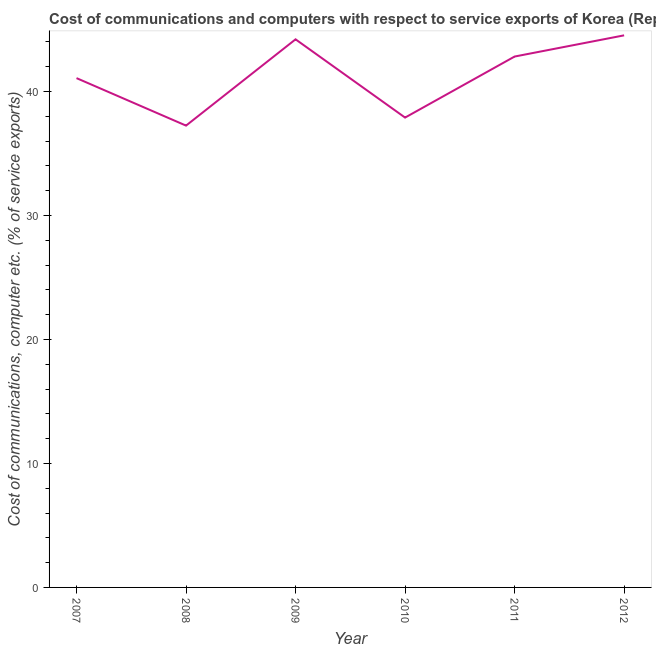What is the cost of communications and computer in 2010?
Offer a very short reply. 37.9. Across all years, what is the maximum cost of communications and computer?
Offer a very short reply. 44.53. Across all years, what is the minimum cost of communications and computer?
Your answer should be compact. 37.25. In which year was the cost of communications and computer maximum?
Give a very brief answer. 2012. In which year was the cost of communications and computer minimum?
Make the answer very short. 2008. What is the sum of the cost of communications and computer?
Make the answer very short. 247.8. What is the difference between the cost of communications and computer in 2010 and 2012?
Your answer should be very brief. -6.63. What is the average cost of communications and computer per year?
Keep it short and to the point. 41.3. What is the median cost of communications and computer?
Give a very brief answer. 41.95. In how many years, is the cost of communications and computer greater than 8 %?
Provide a succinct answer. 6. Do a majority of the years between 2010 and 2009 (inclusive) have cost of communications and computer greater than 16 %?
Provide a succinct answer. No. What is the ratio of the cost of communications and computer in 2008 to that in 2010?
Your answer should be very brief. 0.98. What is the difference between the highest and the second highest cost of communications and computer?
Offer a very short reply. 0.32. What is the difference between the highest and the lowest cost of communications and computer?
Provide a succinct answer. 7.28. How many lines are there?
Ensure brevity in your answer.  1. How many years are there in the graph?
Offer a very short reply. 6. Does the graph contain any zero values?
Your response must be concise. No. What is the title of the graph?
Make the answer very short. Cost of communications and computers with respect to service exports of Korea (Republic). What is the label or title of the Y-axis?
Offer a terse response. Cost of communications, computer etc. (% of service exports). What is the Cost of communications, computer etc. (% of service exports) of 2007?
Provide a succinct answer. 41.08. What is the Cost of communications, computer etc. (% of service exports) in 2008?
Make the answer very short. 37.25. What is the Cost of communications, computer etc. (% of service exports) in 2009?
Your response must be concise. 44.21. What is the Cost of communications, computer etc. (% of service exports) of 2010?
Give a very brief answer. 37.9. What is the Cost of communications, computer etc. (% of service exports) of 2011?
Make the answer very short. 42.82. What is the Cost of communications, computer etc. (% of service exports) of 2012?
Offer a terse response. 44.53. What is the difference between the Cost of communications, computer etc. (% of service exports) in 2007 and 2008?
Provide a short and direct response. 3.83. What is the difference between the Cost of communications, computer etc. (% of service exports) in 2007 and 2009?
Provide a succinct answer. -3.13. What is the difference between the Cost of communications, computer etc. (% of service exports) in 2007 and 2010?
Give a very brief answer. 3.18. What is the difference between the Cost of communications, computer etc. (% of service exports) in 2007 and 2011?
Your response must be concise. -1.74. What is the difference between the Cost of communications, computer etc. (% of service exports) in 2007 and 2012?
Provide a short and direct response. -3.45. What is the difference between the Cost of communications, computer etc. (% of service exports) in 2008 and 2009?
Offer a terse response. -6.96. What is the difference between the Cost of communications, computer etc. (% of service exports) in 2008 and 2010?
Offer a terse response. -0.65. What is the difference between the Cost of communications, computer etc. (% of service exports) in 2008 and 2011?
Give a very brief answer. -5.57. What is the difference between the Cost of communications, computer etc. (% of service exports) in 2008 and 2012?
Ensure brevity in your answer.  -7.28. What is the difference between the Cost of communications, computer etc. (% of service exports) in 2009 and 2010?
Your response must be concise. 6.31. What is the difference between the Cost of communications, computer etc. (% of service exports) in 2009 and 2011?
Provide a succinct answer. 1.39. What is the difference between the Cost of communications, computer etc. (% of service exports) in 2009 and 2012?
Keep it short and to the point. -0.32. What is the difference between the Cost of communications, computer etc. (% of service exports) in 2010 and 2011?
Your response must be concise. -4.92. What is the difference between the Cost of communications, computer etc. (% of service exports) in 2010 and 2012?
Your answer should be compact. -6.63. What is the difference between the Cost of communications, computer etc. (% of service exports) in 2011 and 2012?
Offer a terse response. -1.71. What is the ratio of the Cost of communications, computer etc. (% of service exports) in 2007 to that in 2008?
Give a very brief answer. 1.1. What is the ratio of the Cost of communications, computer etc. (% of service exports) in 2007 to that in 2009?
Make the answer very short. 0.93. What is the ratio of the Cost of communications, computer etc. (% of service exports) in 2007 to that in 2010?
Offer a very short reply. 1.08. What is the ratio of the Cost of communications, computer etc. (% of service exports) in 2007 to that in 2011?
Make the answer very short. 0.96. What is the ratio of the Cost of communications, computer etc. (% of service exports) in 2007 to that in 2012?
Offer a very short reply. 0.92. What is the ratio of the Cost of communications, computer etc. (% of service exports) in 2008 to that in 2009?
Keep it short and to the point. 0.84. What is the ratio of the Cost of communications, computer etc. (% of service exports) in 2008 to that in 2011?
Ensure brevity in your answer.  0.87. What is the ratio of the Cost of communications, computer etc. (% of service exports) in 2008 to that in 2012?
Your answer should be compact. 0.84. What is the ratio of the Cost of communications, computer etc. (% of service exports) in 2009 to that in 2010?
Provide a succinct answer. 1.17. What is the ratio of the Cost of communications, computer etc. (% of service exports) in 2009 to that in 2011?
Offer a terse response. 1.03. What is the ratio of the Cost of communications, computer etc. (% of service exports) in 2009 to that in 2012?
Make the answer very short. 0.99. What is the ratio of the Cost of communications, computer etc. (% of service exports) in 2010 to that in 2011?
Your answer should be very brief. 0.89. What is the ratio of the Cost of communications, computer etc. (% of service exports) in 2010 to that in 2012?
Keep it short and to the point. 0.85. 